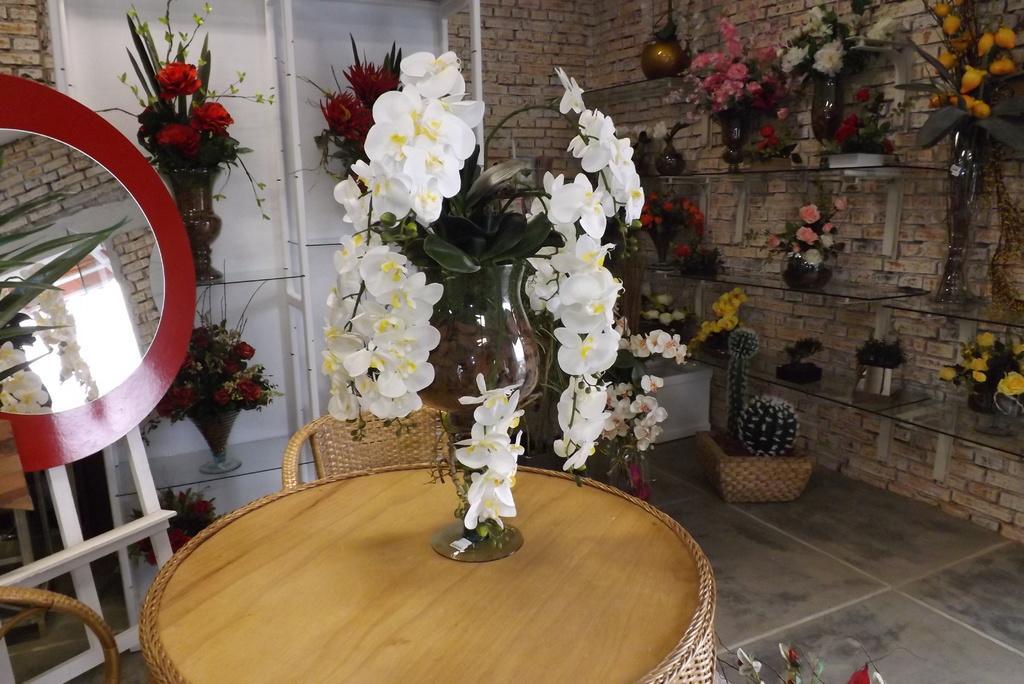Describe this image in one or two sentences. Here we can see a table on the floor and flower vase on it, and here is the rack and vases on it, and at back here is the wall made of bricks. 